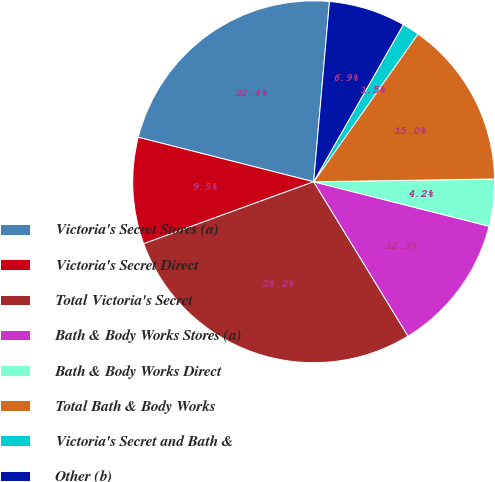<chart> <loc_0><loc_0><loc_500><loc_500><pie_chart><fcel>Victoria's Secret Stores (a)<fcel>Victoria's Secret Direct<fcel>Total Victoria's Secret<fcel>Bath & Body Works Stores (a)<fcel>Bath & Body Works Direct<fcel>Total Bath & Body Works<fcel>Victoria's Secret and Bath &<fcel>Other (b)<nl><fcel>22.44%<fcel>9.52%<fcel>28.17%<fcel>12.31%<fcel>4.2%<fcel>14.97%<fcel>1.53%<fcel>6.86%<nl></chart> 